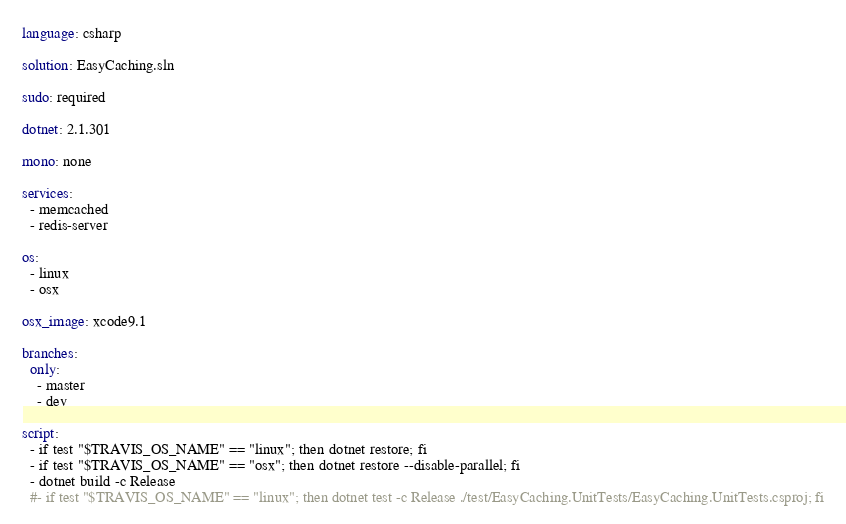<code> <loc_0><loc_0><loc_500><loc_500><_YAML_>language: csharp

solution: EasyCaching.sln

sudo: required
    
dotnet: 2.1.301

mono: none

services:
  - memcached
  - redis-server

os:
  - linux
  - osx
  
osx_image: xcode9.1

branches:
  only:
    - master
    - dev
 
script:
  - if test "$TRAVIS_OS_NAME" == "linux"; then dotnet restore; fi
  - if test "$TRAVIS_OS_NAME" == "osx"; then dotnet restore --disable-parallel; fi
  - dotnet build -c Release
  #- if test "$TRAVIS_OS_NAME" == "linux"; then dotnet test -c Release ./test/EasyCaching.UnitTests/EasyCaching.UnitTests.csproj; fi
</code> 